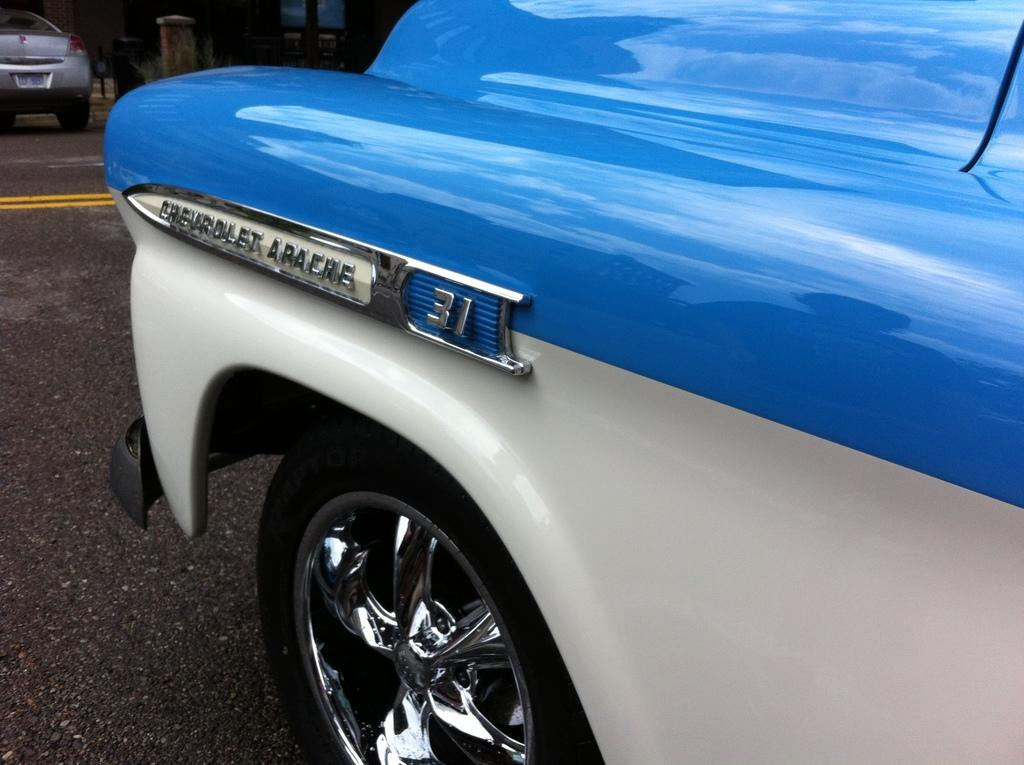What is happening on the road in the image? There are vehicles on the road in the image. Can you describe what is visible in the background of the image? Unfortunately, the provided facts do not give any specific details about the objects visible in the background. How many boys are playing with a hammer in the image? There are no boys or hammers present in the image. 